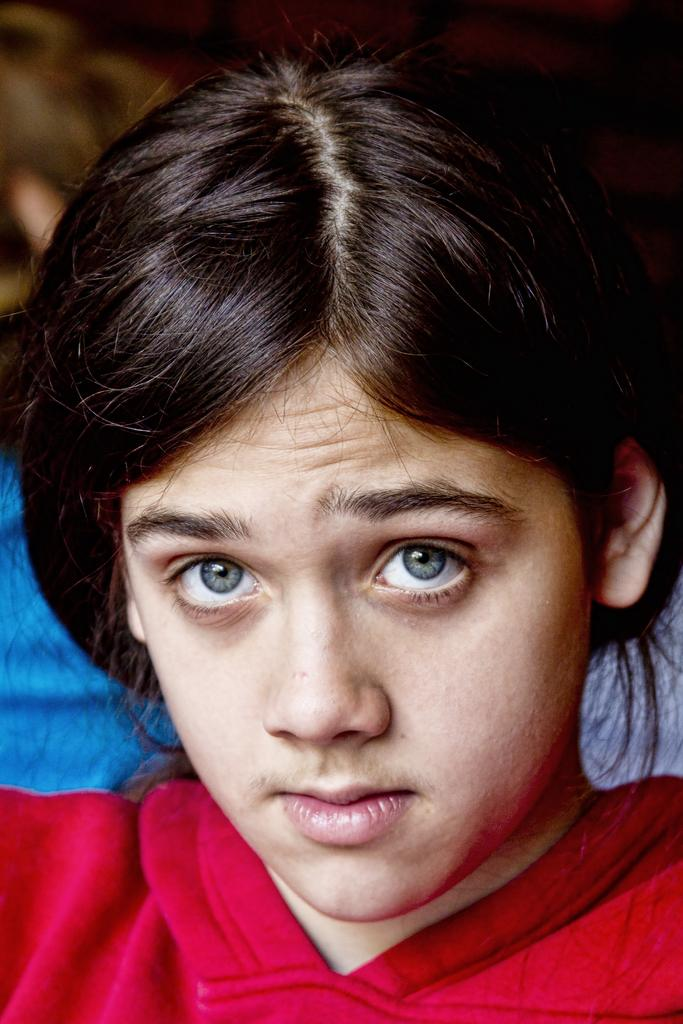What is the main subject of the image? The main subject of the image is a person's face. What type of coast can be seen in the background of the image? There is no coast visible in the image; it only features a person's face. What type of stove is being used by the person in the image? There is no stove present in the image; it only features a person's face. 